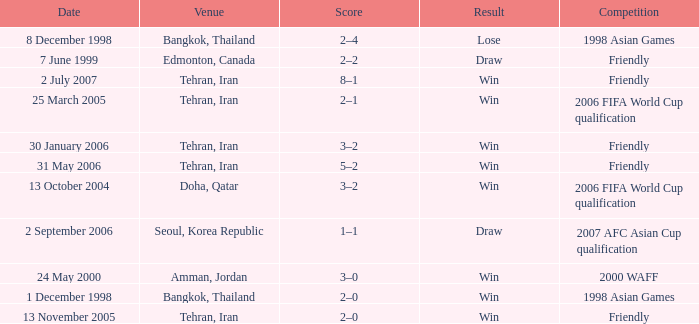What was the competition on 13 November 2005? Friendly. 